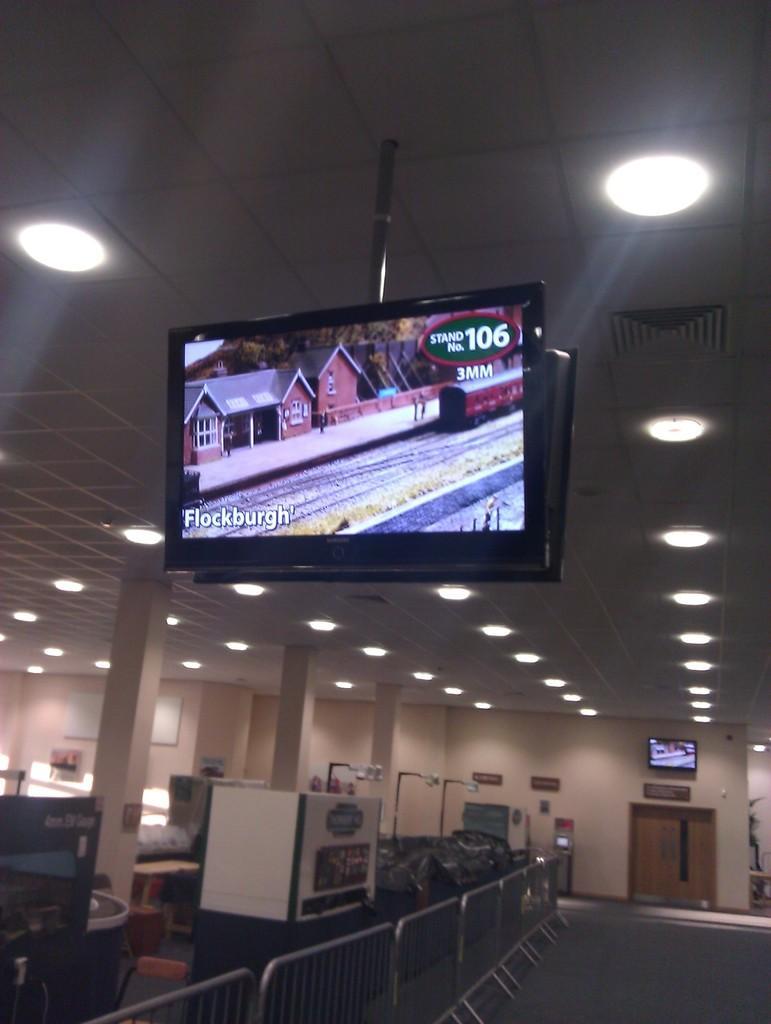How would you summarize this image in a sentence or two? In the center of the image there are two TVs. There are railings. At the bottom of the image there is a mat. On the left side of the image there are few objects. In the background of the image there is a door. There is a TV and there are name boards on the wall. On top of the image there are lights. 